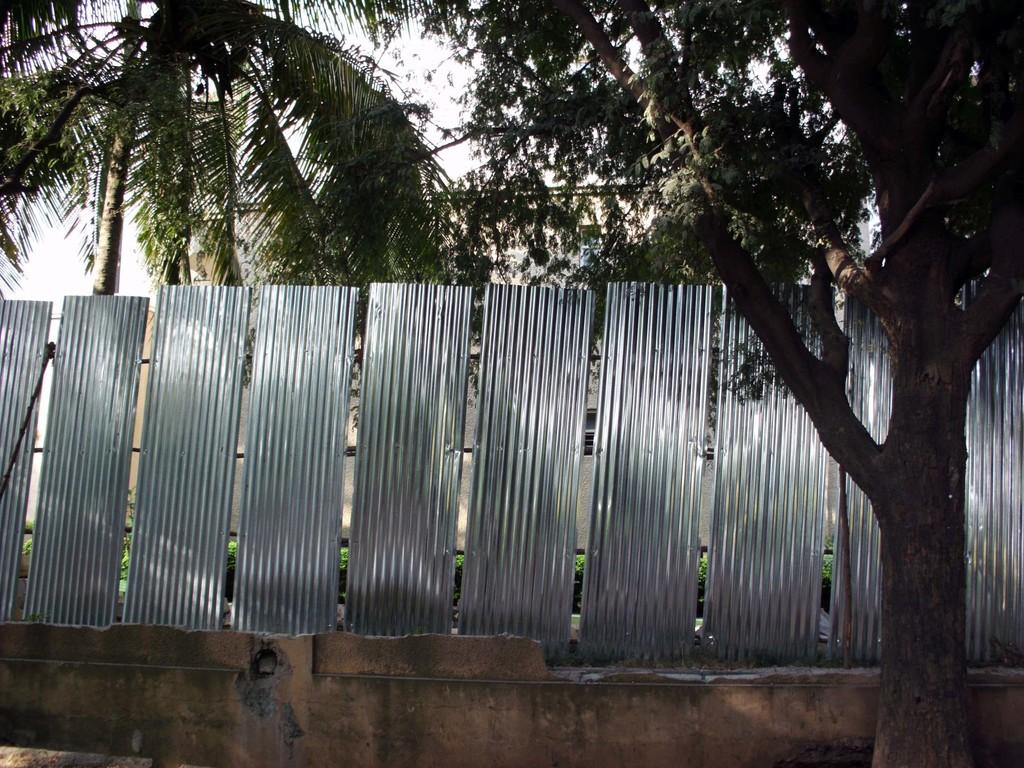What type of vegetation can be seen in the image? There are trees in the image. What is located in the center of the image? There are objects in the center of the image. What is at the bottom of the image? There is a wall at the bottom of the image. What can be seen in the background of the image? There are trees and the sky visible in the background of the image. Reasoning: Let' Let's think step by step in order to produce the conversation. We start by identifying the main subjects and objects in the image based on the provided facts. We then formulate questions that focus on the location and characteristics of these subjects and objects, ensuring that each question can be answered definitively with the information given. We avoid yes/no questions and ensure that the language is simple and clear. Absurd Question/Answer: How many kittens are playing with an orange in the image? There are no kittens or oranges present in the image. What advice does the uncle give in the image? There is no uncle or any conversation depicted in the image. 